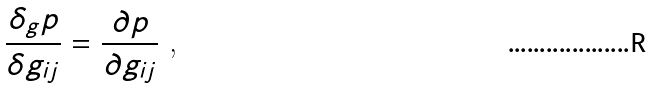<formula> <loc_0><loc_0><loc_500><loc_500>\frac { \delta _ { g } p } { \delta g _ { i j } } = \frac { \partial p } { \partial g _ { i j } } \text { ,}</formula> 